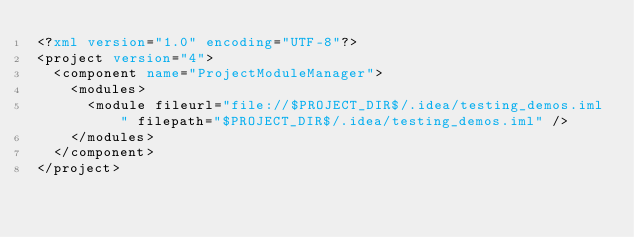<code> <loc_0><loc_0><loc_500><loc_500><_XML_><?xml version="1.0" encoding="UTF-8"?>
<project version="4">
  <component name="ProjectModuleManager">
    <modules>
      <module fileurl="file://$PROJECT_DIR$/.idea/testing_demos.iml" filepath="$PROJECT_DIR$/.idea/testing_demos.iml" />
    </modules>
  </component>
</project></code> 